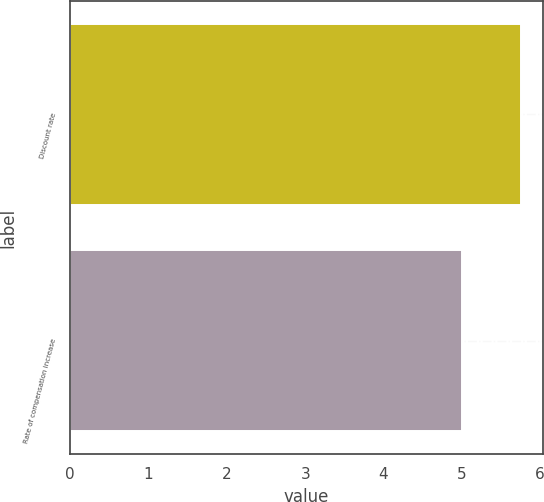<chart> <loc_0><loc_0><loc_500><loc_500><bar_chart><fcel>Discount rate<fcel>Rate of compensation increase<nl><fcel>5.75<fcel>5<nl></chart> 